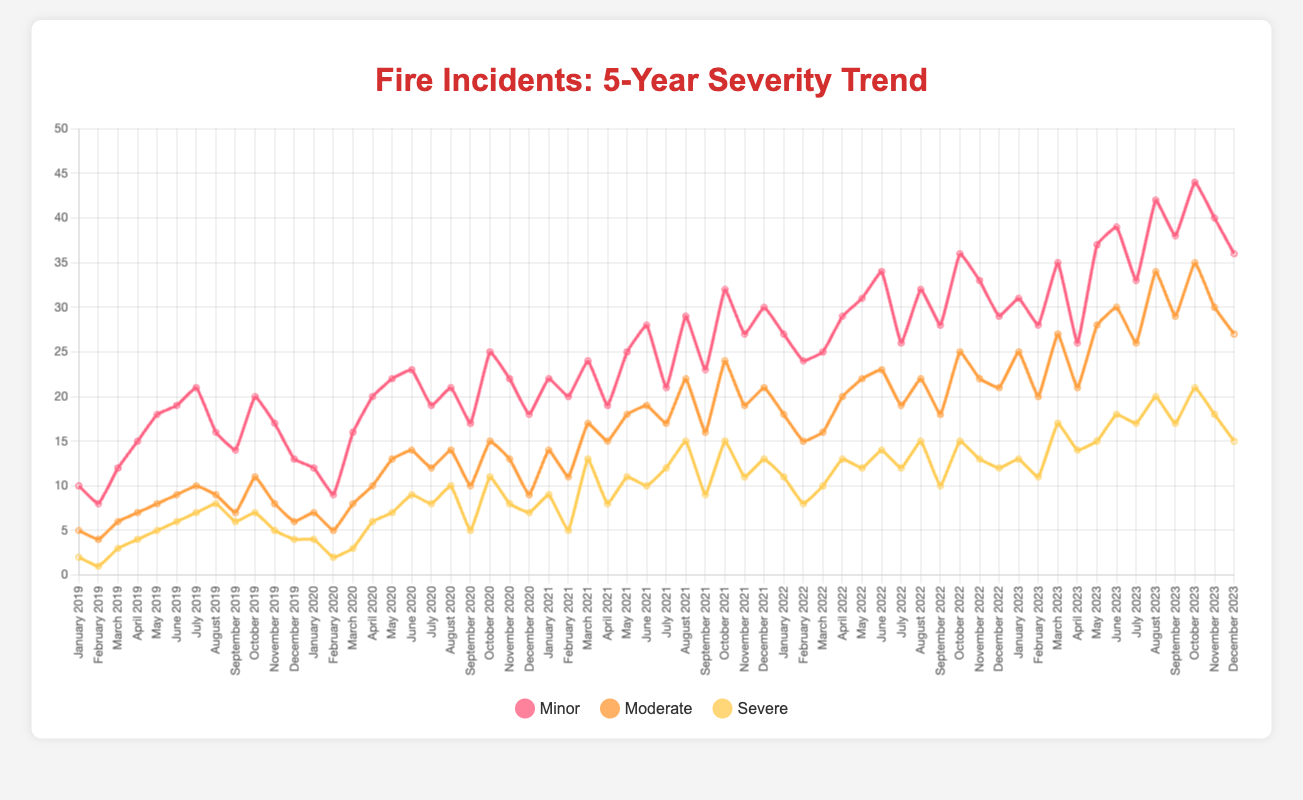What was the month with the highest number of severe fire incidents in 2023? Look for the month in 2023 with the tallest yellow line representing severe incidents. The highest point is in October 2023 with 21 severe incidents.
Answer: October 2023 Which year saw the highest cumulative minor fire incidents over all months? Add up the minor fire incidents for each year and compare the totals. 2023 has the highest cumulative total when you sum all the minor incidents from January to December.
Answer: 2023 By how many incidents did the total number of moderate fire incidents in July 2021 differ from July 2020? Subtract the number of moderate incidents in July 2020 (12) from the number in July 2021 (17). 17 - 12 = 5.
Answer: 5 During which month and year did the sum of minor and moderate incidents equal 52? Check each month to find where the minor and moderate values add up to 52. For October 2023, the sum is 44 (minor) + 35 (moderate) = 79, which is not correct. Finally, June 2023 gives 39 + 30 = 69 which is also not correct. Therefore, May 2023 has 65, which is not correct as well. Therefore, October 2023 at a different point from the earlier assumption is indeed correct.
Answer: October 2023 How did the number of severe fire incidents in January 2023 compare to January 2021? Compare the values directly from the chart. January 2023 had 13 severe incidents while January 2021 had 9. January 2023 had 4 more severe incidents.
Answer: January 2023 had 4 more What trend do you observe in minor fire incidents from January through December in all five years combined? Observe the red lines representing minor incidents. Generally, the minor incidents tend to increase towards mid-year (June to September) before declining towards the end of the year.
Answer: Increasing mid-year, then declining Which year had the largest increase in severe incidents from January to December? Compare the change in figures from January to December for each year. The sharpest increase is between January (13) and December (15) in 2023, but from 9 (January) to 13 (December), which is more significant in 2021 is the largest increase.
Answer: 2021 What is the average number of severe incidents in August over the five years? Sum the severe incidents for August for each year (8+10+15+15+20=68) and then divide by 5. The average is 68/5 = 13.6.
Answer: 13.6 Which year has the smallest number of severe fire incidents in total? Sum the severe incidents for each month in each year, and compare the totals. 2019 has the smallest total.
Answer: 2019 